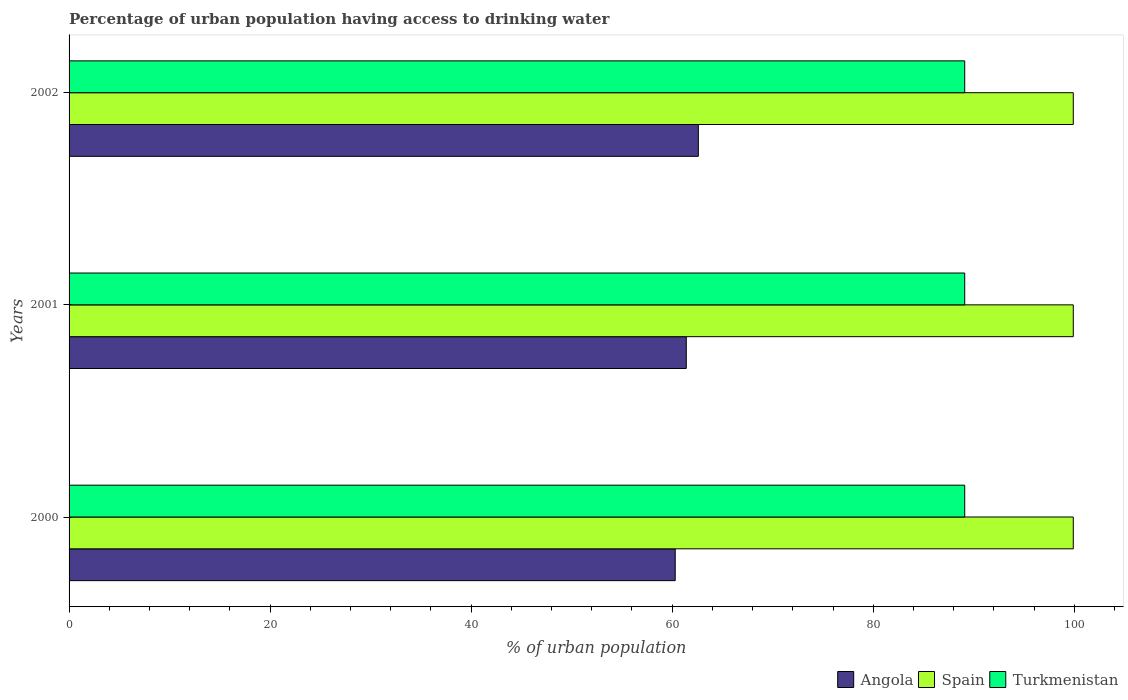How many different coloured bars are there?
Give a very brief answer. 3. Are the number of bars per tick equal to the number of legend labels?
Ensure brevity in your answer.  Yes. Are the number of bars on each tick of the Y-axis equal?
Provide a short and direct response. Yes. How many bars are there on the 1st tick from the top?
Provide a short and direct response. 3. What is the label of the 2nd group of bars from the top?
Your answer should be very brief. 2001. What is the percentage of urban population having access to drinking water in Spain in 2001?
Keep it short and to the point. 99.9. Across all years, what is the maximum percentage of urban population having access to drinking water in Turkmenistan?
Your answer should be very brief. 89.1. Across all years, what is the minimum percentage of urban population having access to drinking water in Angola?
Provide a short and direct response. 60.3. What is the total percentage of urban population having access to drinking water in Angola in the graph?
Provide a short and direct response. 184.3. What is the difference between the percentage of urban population having access to drinking water in Turkmenistan in 2000 and the percentage of urban population having access to drinking water in Spain in 2002?
Provide a short and direct response. -10.8. What is the average percentage of urban population having access to drinking water in Turkmenistan per year?
Provide a short and direct response. 89.1. In the year 2001, what is the difference between the percentage of urban population having access to drinking water in Angola and percentage of urban population having access to drinking water in Spain?
Provide a succinct answer. -38.5. In how many years, is the percentage of urban population having access to drinking water in Spain greater than 52 %?
Make the answer very short. 3. What is the ratio of the percentage of urban population having access to drinking water in Spain in 2001 to that in 2002?
Ensure brevity in your answer.  1. Is the percentage of urban population having access to drinking water in Angola in 2001 less than that in 2002?
Keep it short and to the point. Yes. What is the difference between the highest and the lowest percentage of urban population having access to drinking water in Turkmenistan?
Your answer should be compact. 0. In how many years, is the percentage of urban population having access to drinking water in Angola greater than the average percentage of urban population having access to drinking water in Angola taken over all years?
Keep it short and to the point. 1. Is the sum of the percentage of urban population having access to drinking water in Angola in 2001 and 2002 greater than the maximum percentage of urban population having access to drinking water in Turkmenistan across all years?
Keep it short and to the point. Yes. What does the 1st bar from the top in 2001 represents?
Your response must be concise. Turkmenistan. What does the 2nd bar from the bottom in 2000 represents?
Your response must be concise. Spain. Is it the case that in every year, the sum of the percentage of urban population having access to drinking water in Angola and percentage of urban population having access to drinking water in Turkmenistan is greater than the percentage of urban population having access to drinking water in Spain?
Provide a short and direct response. Yes. How many years are there in the graph?
Your answer should be very brief. 3. What is the difference between two consecutive major ticks on the X-axis?
Provide a succinct answer. 20. Are the values on the major ticks of X-axis written in scientific E-notation?
Make the answer very short. No. Does the graph contain any zero values?
Your response must be concise. No. How many legend labels are there?
Provide a short and direct response. 3. How are the legend labels stacked?
Your response must be concise. Horizontal. What is the title of the graph?
Make the answer very short. Percentage of urban population having access to drinking water. Does "Estonia" appear as one of the legend labels in the graph?
Make the answer very short. No. What is the label or title of the X-axis?
Give a very brief answer. % of urban population. What is the % of urban population of Angola in 2000?
Ensure brevity in your answer.  60.3. What is the % of urban population in Spain in 2000?
Offer a terse response. 99.9. What is the % of urban population of Turkmenistan in 2000?
Offer a terse response. 89.1. What is the % of urban population of Angola in 2001?
Offer a very short reply. 61.4. What is the % of urban population in Spain in 2001?
Make the answer very short. 99.9. What is the % of urban population of Turkmenistan in 2001?
Keep it short and to the point. 89.1. What is the % of urban population of Angola in 2002?
Your answer should be compact. 62.6. What is the % of urban population of Spain in 2002?
Your answer should be very brief. 99.9. What is the % of urban population in Turkmenistan in 2002?
Offer a terse response. 89.1. Across all years, what is the maximum % of urban population of Angola?
Your response must be concise. 62.6. Across all years, what is the maximum % of urban population in Spain?
Your answer should be compact. 99.9. Across all years, what is the maximum % of urban population in Turkmenistan?
Keep it short and to the point. 89.1. Across all years, what is the minimum % of urban population in Angola?
Provide a succinct answer. 60.3. Across all years, what is the minimum % of urban population in Spain?
Provide a succinct answer. 99.9. Across all years, what is the minimum % of urban population of Turkmenistan?
Your answer should be compact. 89.1. What is the total % of urban population of Angola in the graph?
Offer a very short reply. 184.3. What is the total % of urban population of Spain in the graph?
Your answer should be compact. 299.7. What is the total % of urban population of Turkmenistan in the graph?
Offer a very short reply. 267.3. What is the difference between the % of urban population in Spain in 2000 and that in 2001?
Offer a terse response. 0. What is the difference between the % of urban population in Angola in 2000 and that in 2002?
Your answer should be compact. -2.3. What is the difference between the % of urban population in Turkmenistan in 2000 and that in 2002?
Provide a short and direct response. 0. What is the difference between the % of urban population of Angola in 2001 and that in 2002?
Provide a succinct answer. -1.2. What is the difference between the % of urban population of Spain in 2001 and that in 2002?
Give a very brief answer. 0. What is the difference between the % of urban population of Turkmenistan in 2001 and that in 2002?
Your response must be concise. 0. What is the difference between the % of urban population in Angola in 2000 and the % of urban population in Spain in 2001?
Your response must be concise. -39.6. What is the difference between the % of urban population of Angola in 2000 and the % of urban population of Turkmenistan in 2001?
Make the answer very short. -28.8. What is the difference between the % of urban population of Angola in 2000 and the % of urban population of Spain in 2002?
Keep it short and to the point. -39.6. What is the difference between the % of urban population in Angola in 2000 and the % of urban population in Turkmenistan in 2002?
Provide a short and direct response. -28.8. What is the difference between the % of urban population in Spain in 2000 and the % of urban population in Turkmenistan in 2002?
Offer a terse response. 10.8. What is the difference between the % of urban population in Angola in 2001 and the % of urban population in Spain in 2002?
Keep it short and to the point. -38.5. What is the difference between the % of urban population in Angola in 2001 and the % of urban population in Turkmenistan in 2002?
Your answer should be very brief. -27.7. What is the difference between the % of urban population of Spain in 2001 and the % of urban population of Turkmenistan in 2002?
Keep it short and to the point. 10.8. What is the average % of urban population in Angola per year?
Your response must be concise. 61.43. What is the average % of urban population in Spain per year?
Make the answer very short. 99.9. What is the average % of urban population of Turkmenistan per year?
Your response must be concise. 89.1. In the year 2000, what is the difference between the % of urban population of Angola and % of urban population of Spain?
Keep it short and to the point. -39.6. In the year 2000, what is the difference between the % of urban population in Angola and % of urban population in Turkmenistan?
Provide a succinct answer. -28.8. In the year 2000, what is the difference between the % of urban population in Spain and % of urban population in Turkmenistan?
Your answer should be very brief. 10.8. In the year 2001, what is the difference between the % of urban population of Angola and % of urban population of Spain?
Your answer should be very brief. -38.5. In the year 2001, what is the difference between the % of urban population in Angola and % of urban population in Turkmenistan?
Provide a succinct answer. -27.7. In the year 2001, what is the difference between the % of urban population of Spain and % of urban population of Turkmenistan?
Offer a terse response. 10.8. In the year 2002, what is the difference between the % of urban population in Angola and % of urban population in Spain?
Your answer should be very brief. -37.3. In the year 2002, what is the difference between the % of urban population in Angola and % of urban population in Turkmenistan?
Your response must be concise. -26.5. In the year 2002, what is the difference between the % of urban population of Spain and % of urban population of Turkmenistan?
Make the answer very short. 10.8. What is the ratio of the % of urban population in Angola in 2000 to that in 2001?
Your response must be concise. 0.98. What is the ratio of the % of urban population of Spain in 2000 to that in 2001?
Your response must be concise. 1. What is the ratio of the % of urban population in Angola in 2000 to that in 2002?
Your answer should be very brief. 0.96. What is the ratio of the % of urban population in Spain in 2000 to that in 2002?
Provide a short and direct response. 1. What is the ratio of the % of urban population of Turkmenistan in 2000 to that in 2002?
Provide a succinct answer. 1. What is the ratio of the % of urban population of Angola in 2001 to that in 2002?
Your answer should be very brief. 0.98. What is the ratio of the % of urban population of Turkmenistan in 2001 to that in 2002?
Offer a very short reply. 1. What is the difference between the highest and the second highest % of urban population in Angola?
Provide a succinct answer. 1.2. What is the difference between the highest and the second highest % of urban population of Spain?
Your answer should be very brief. 0. What is the difference between the highest and the lowest % of urban population of Angola?
Offer a terse response. 2.3. What is the difference between the highest and the lowest % of urban population in Spain?
Offer a terse response. 0. What is the difference between the highest and the lowest % of urban population of Turkmenistan?
Provide a succinct answer. 0. 